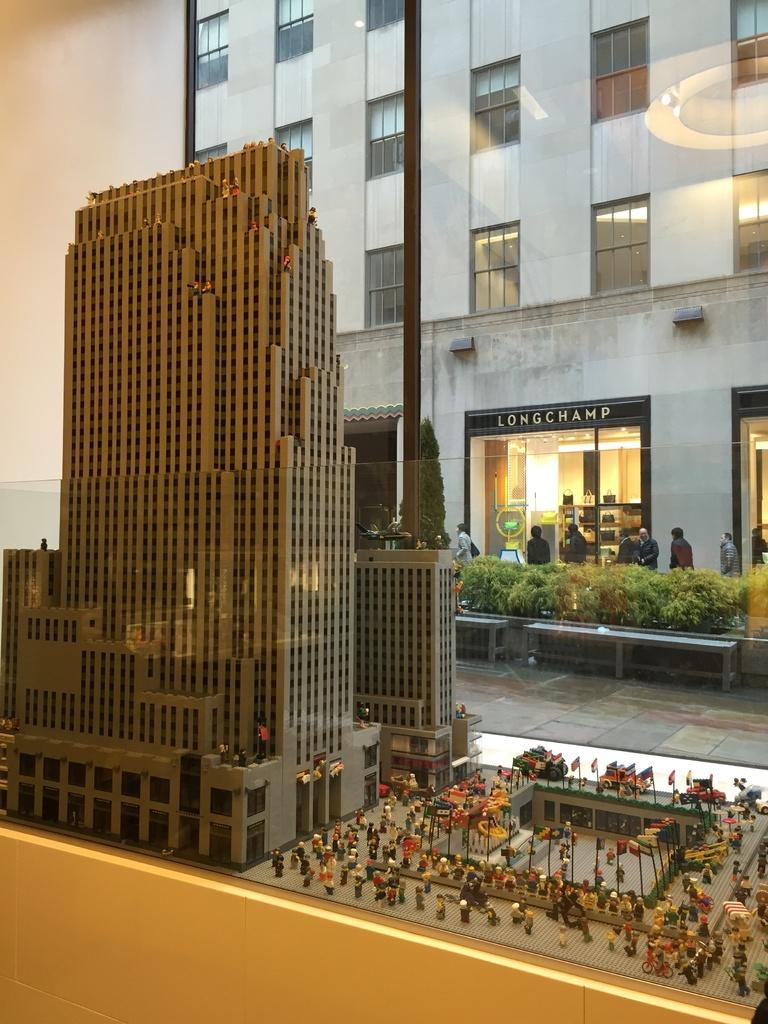What type of objects can be seen in the image? There are toys in the image. What type of structures are visible in the image? There are buildings with windows in the image. Who or what is present in the image? There are people in the image. What type of vegetation is visible in the image? There are plants in the image. What can be seen beneath the people and structures in the image? The ground is visible in the image. Can you see any pets interacting with the people in the image? There is no mention of pets in the image, so we cannot determine if any are present or interacting with the people. What type of turkey can be seen in the image? There is no turkey present in the image. 